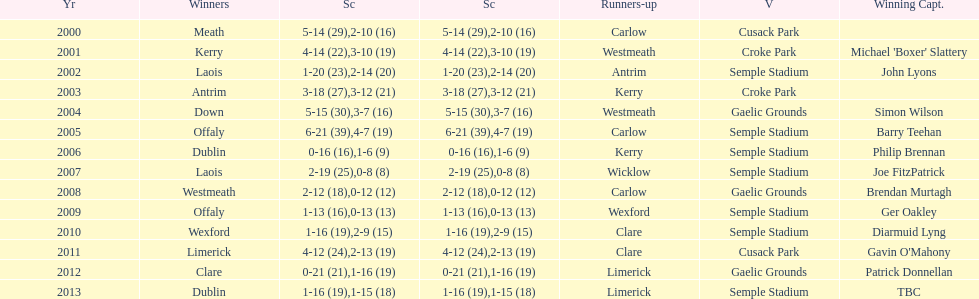Who was the first winner in 2013? Dublin. 